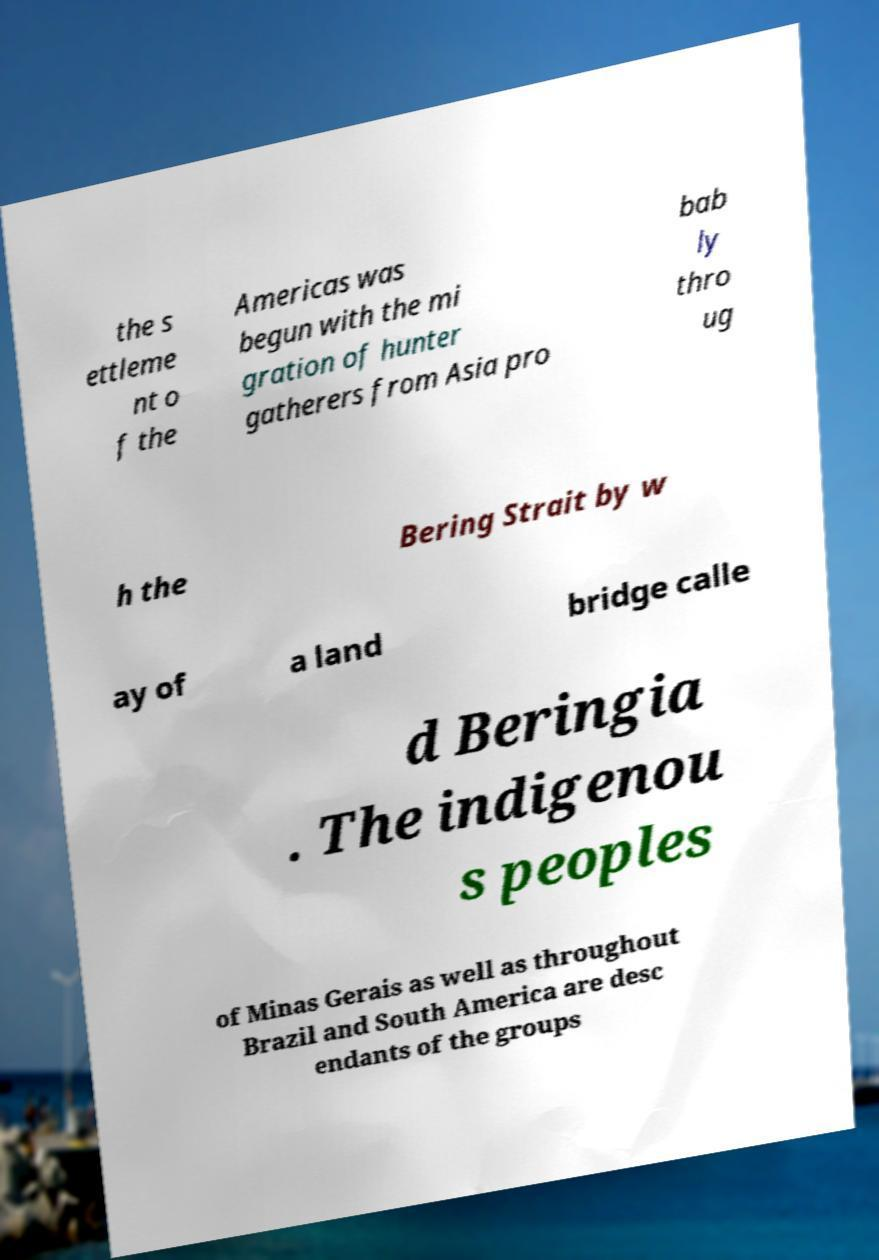What messages or text are displayed in this image? I need them in a readable, typed format. the s ettleme nt o f the Americas was begun with the mi gration of hunter gatherers from Asia pro bab ly thro ug h the Bering Strait by w ay of a land bridge calle d Beringia . The indigenou s peoples of Minas Gerais as well as throughout Brazil and South America are desc endants of the groups 